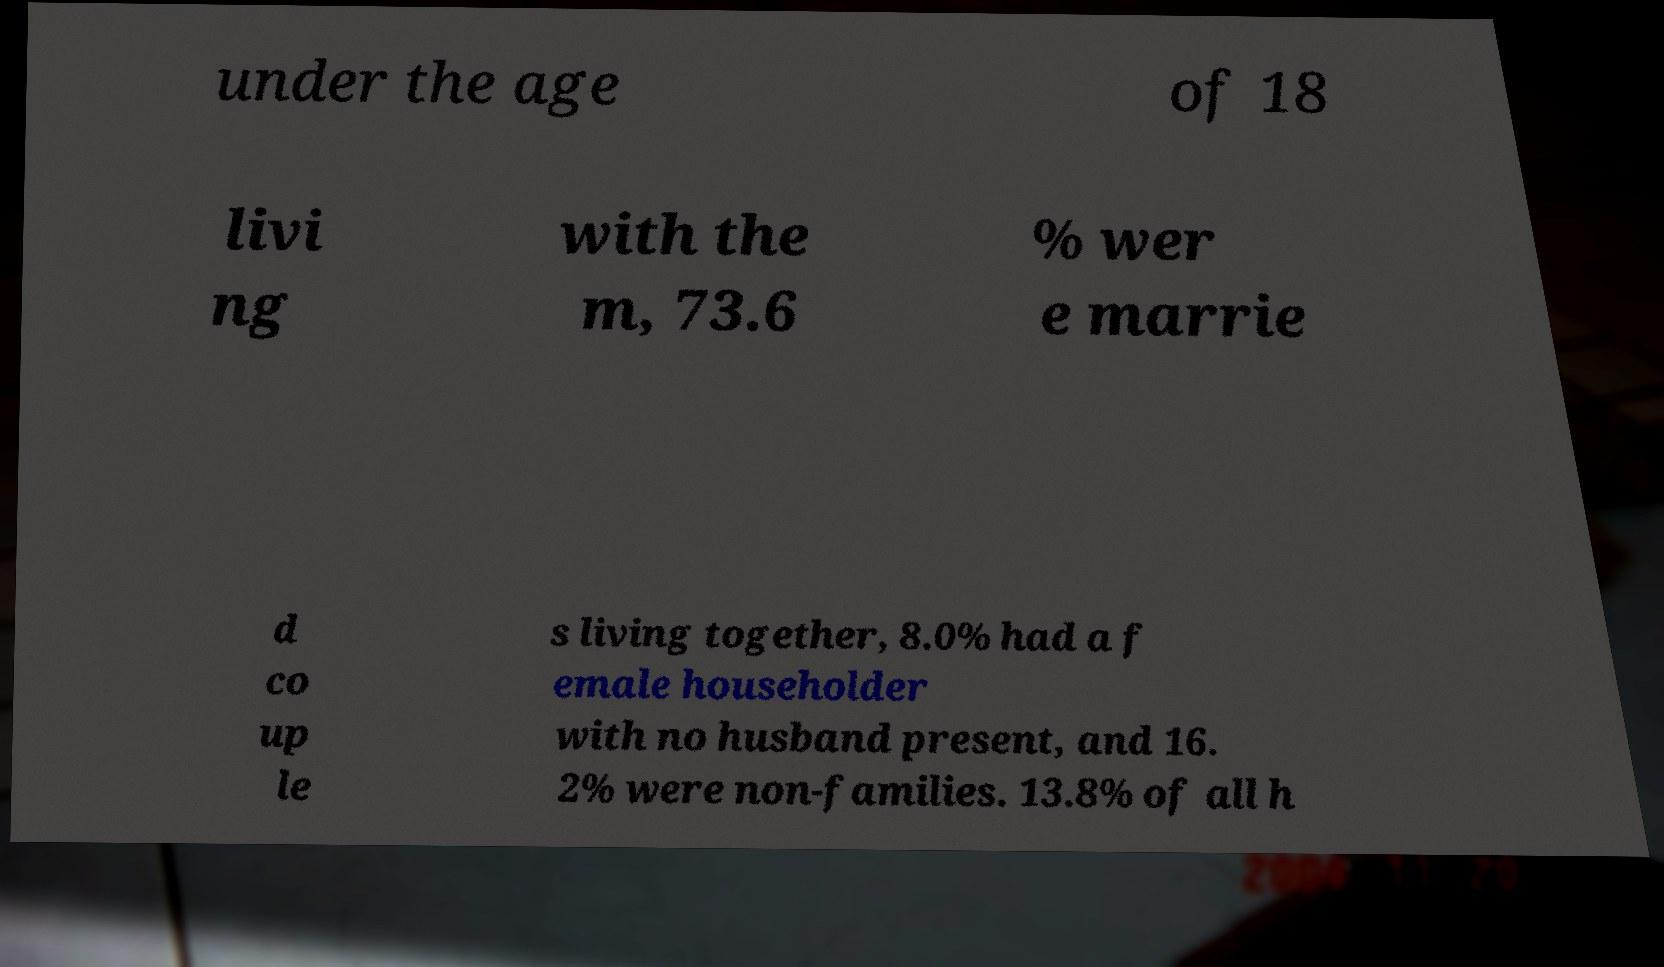Please read and relay the text visible in this image. What does it say? under the age of 18 livi ng with the m, 73.6 % wer e marrie d co up le s living together, 8.0% had a f emale householder with no husband present, and 16. 2% were non-families. 13.8% of all h 